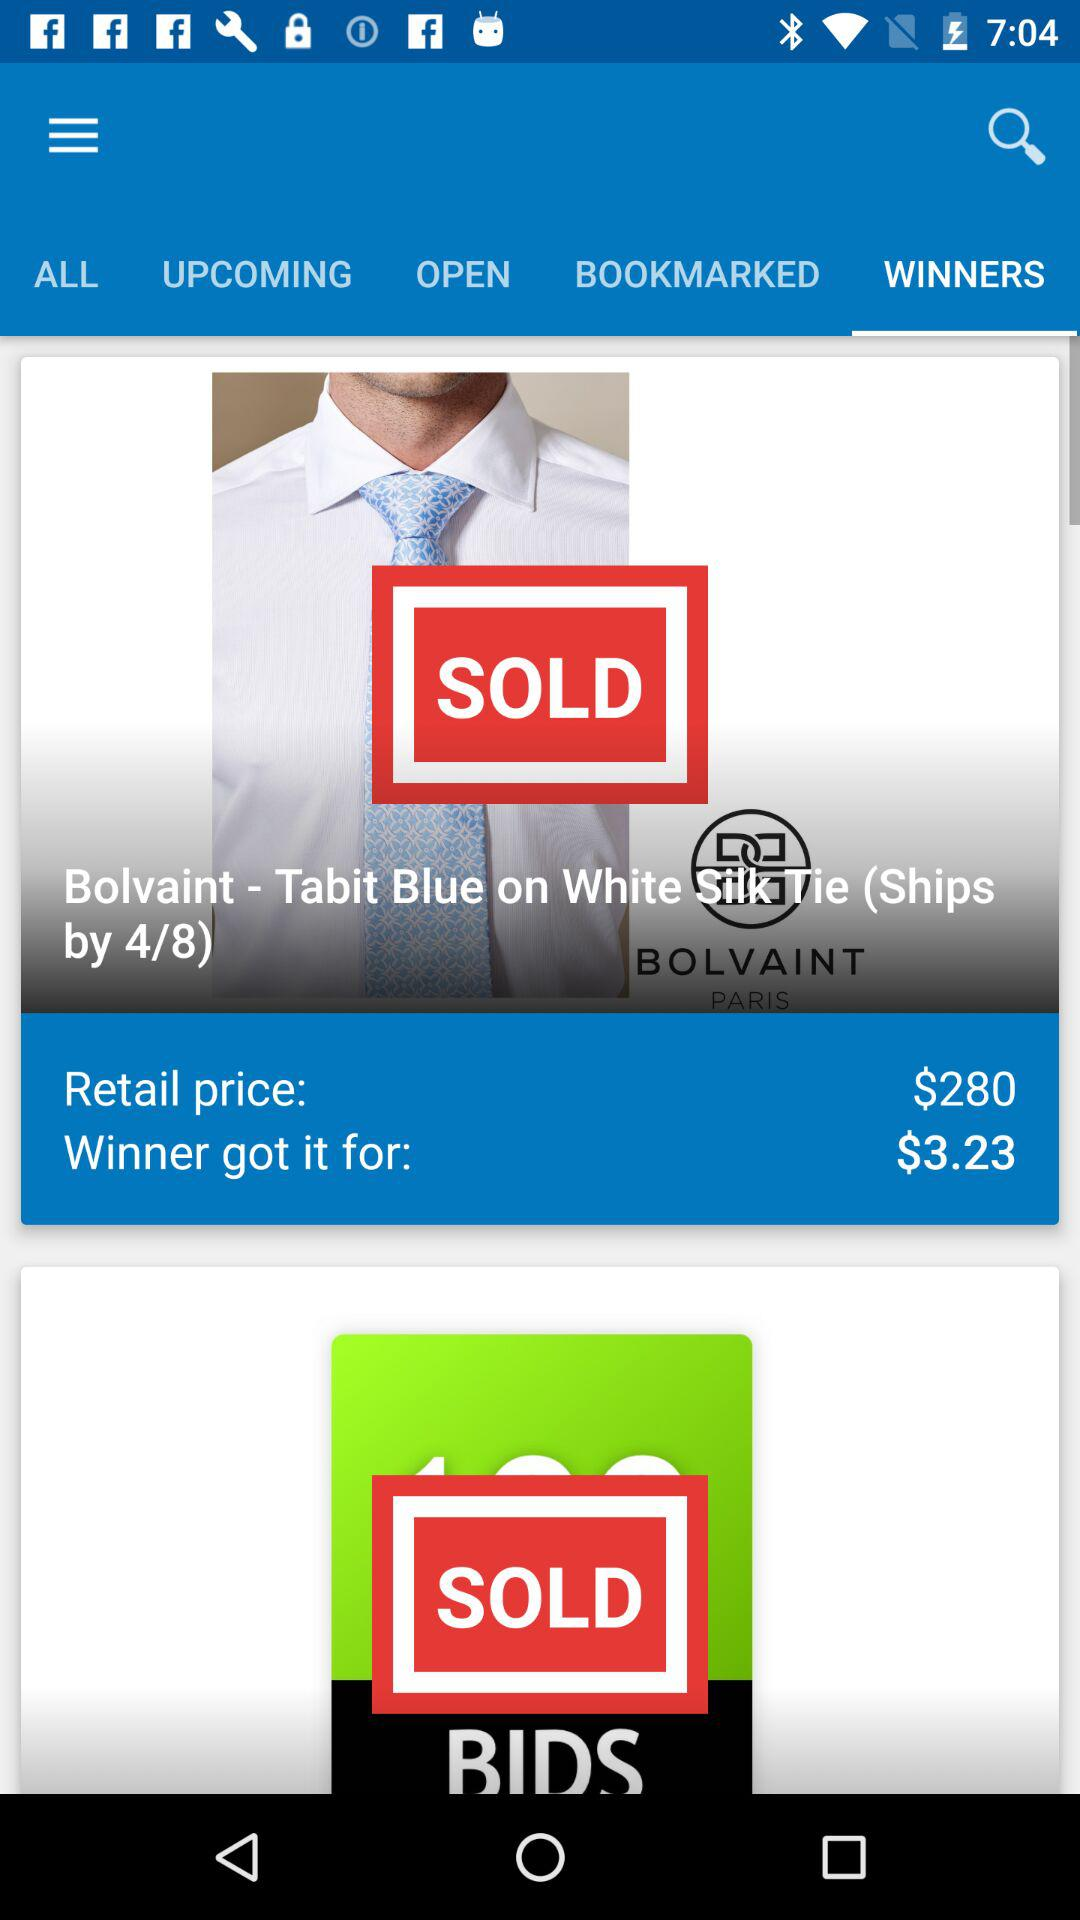How much more is the winner's price than the retail price?
Answer the question using a single word or phrase. $276.77 